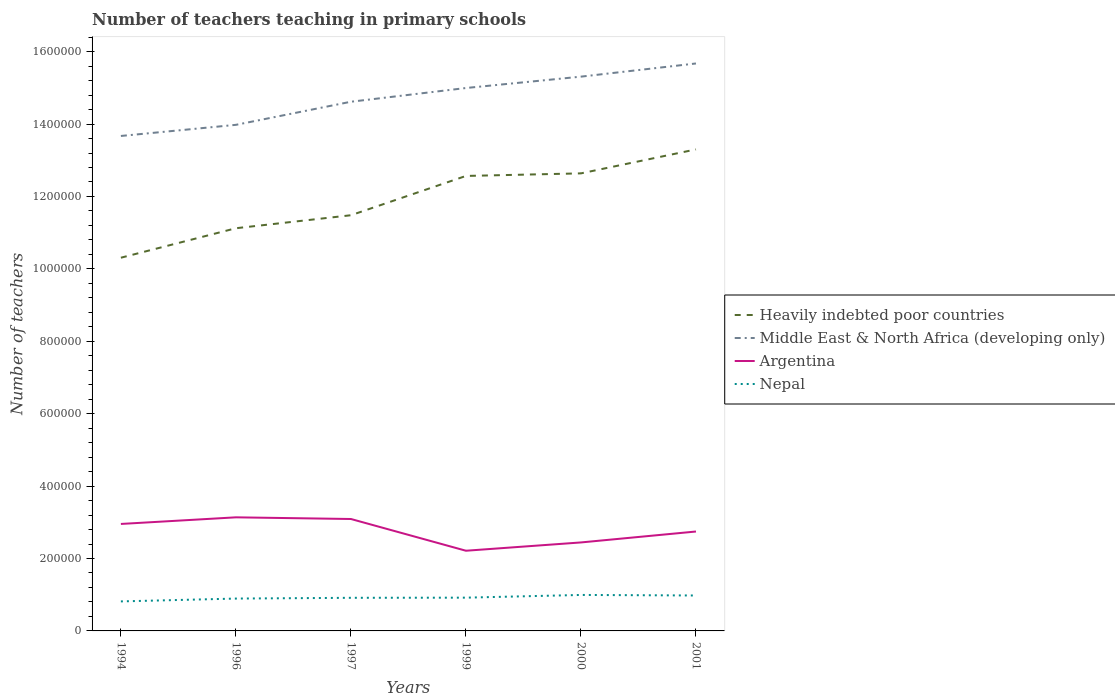How many different coloured lines are there?
Ensure brevity in your answer.  4. Does the line corresponding to Nepal intersect with the line corresponding to Argentina?
Ensure brevity in your answer.  No. Across all years, what is the maximum number of teachers teaching in primary schools in Heavily indebted poor countries?
Offer a terse response. 1.03e+06. What is the total number of teachers teaching in primary schools in Nepal in the graph?
Offer a terse response. -1.63e+04. What is the difference between the highest and the second highest number of teachers teaching in primary schools in Argentina?
Your response must be concise. 9.23e+04. How many years are there in the graph?
Offer a very short reply. 6. What is the difference between two consecutive major ticks on the Y-axis?
Your answer should be very brief. 2.00e+05. Are the values on the major ticks of Y-axis written in scientific E-notation?
Your response must be concise. No. How many legend labels are there?
Make the answer very short. 4. What is the title of the graph?
Offer a very short reply. Number of teachers teaching in primary schools. Does "Austria" appear as one of the legend labels in the graph?
Your answer should be very brief. No. What is the label or title of the Y-axis?
Give a very brief answer. Number of teachers. What is the Number of teachers of Heavily indebted poor countries in 1994?
Offer a very short reply. 1.03e+06. What is the Number of teachers of Middle East & North Africa (developing only) in 1994?
Your response must be concise. 1.37e+06. What is the Number of teachers in Argentina in 1994?
Your answer should be compact. 2.95e+05. What is the Number of teachers of Nepal in 1994?
Your response must be concise. 8.15e+04. What is the Number of teachers in Heavily indebted poor countries in 1996?
Make the answer very short. 1.11e+06. What is the Number of teachers of Middle East & North Africa (developing only) in 1996?
Make the answer very short. 1.40e+06. What is the Number of teachers of Argentina in 1996?
Provide a succinct answer. 3.14e+05. What is the Number of teachers in Nepal in 1996?
Provide a short and direct response. 8.94e+04. What is the Number of teachers of Heavily indebted poor countries in 1997?
Your answer should be compact. 1.15e+06. What is the Number of teachers in Middle East & North Africa (developing only) in 1997?
Provide a short and direct response. 1.46e+06. What is the Number of teachers in Argentina in 1997?
Ensure brevity in your answer.  3.09e+05. What is the Number of teachers of Nepal in 1997?
Make the answer very short. 9.15e+04. What is the Number of teachers in Heavily indebted poor countries in 1999?
Provide a succinct answer. 1.26e+06. What is the Number of teachers in Middle East & North Africa (developing only) in 1999?
Provide a succinct answer. 1.50e+06. What is the Number of teachers in Argentina in 1999?
Your answer should be very brief. 2.21e+05. What is the Number of teachers of Nepal in 1999?
Provide a succinct answer. 9.19e+04. What is the Number of teachers in Heavily indebted poor countries in 2000?
Keep it short and to the point. 1.26e+06. What is the Number of teachers in Middle East & North Africa (developing only) in 2000?
Provide a short and direct response. 1.53e+06. What is the Number of teachers of Argentina in 2000?
Provide a succinct answer. 2.44e+05. What is the Number of teachers in Nepal in 2000?
Provide a succinct answer. 9.94e+04. What is the Number of teachers of Heavily indebted poor countries in 2001?
Give a very brief answer. 1.33e+06. What is the Number of teachers of Middle East & North Africa (developing only) in 2001?
Your response must be concise. 1.57e+06. What is the Number of teachers of Argentina in 2001?
Make the answer very short. 2.75e+05. What is the Number of teachers in Nepal in 2001?
Your answer should be compact. 9.79e+04. Across all years, what is the maximum Number of teachers in Heavily indebted poor countries?
Provide a succinct answer. 1.33e+06. Across all years, what is the maximum Number of teachers of Middle East & North Africa (developing only)?
Give a very brief answer. 1.57e+06. Across all years, what is the maximum Number of teachers of Argentina?
Ensure brevity in your answer.  3.14e+05. Across all years, what is the maximum Number of teachers in Nepal?
Provide a succinct answer. 9.94e+04. Across all years, what is the minimum Number of teachers of Heavily indebted poor countries?
Provide a succinct answer. 1.03e+06. Across all years, what is the minimum Number of teachers of Middle East & North Africa (developing only)?
Your response must be concise. 1.37e+06. Across all years, what is the minimum Number of teachers in Argentina?
Provide a succinct answer. 2.21e+05. Across all years, what is the minimum Number of teachers of Nepal?
Offer a very short reply. 8.15e+04. What is the total Number of teachers in Heavily indebted poor countries in the graph?
Make the answer very short. 7.14e+06. What is the total Number of teachers in Middle East & North Africa (developing only) in the graph?
Offer a very short reply. 8.82e+06. What is the total Number of teachers in Argentina in the graph?
Give a very brief answer. 1.66e+06. What is the total Number of teachers of Nepal in the graph?
Your answer should be compact. 5.52e+05. What is the difference between the Number of teachers in Heavily indebted poor countries in 1994 and that in 1996?
Give a very brief answer. -8.15e+04. What is the difference between the Number of teachers in Middle East & North Africa (developing only) in 1994 and that in 1996?
Keep it short and to the point. -3.07e+04. What is the difference between the Number of teachers of Argentina in 1994 and that in 1996?
Your response must be concise. -1.83e+04. What is the difference between the Number of teachers in Nepal in 1994 and that in 1996?
Make the answer very short. -7834. What is the difference between the Number of teachers of Heavily indebted poor countries in 1994 and that in 1997?
Offer a terse response. -1.17e+05. What is the difference between the Number of teachers in Middle East & North Africa (developing only) in 1994 and that in 1997?
Your answer should be compact. -9.45e+04. What is the difference between the Number of teachers of Argentina in 1994 and that in 1997?
Give a very brief answer. -1.37e+04. What is the difference between the Number of teachers in Nepal in 1994 and that in 1997?
Your response must be concise. -9920. What is the difference between the Number of teachers of Heavily indebted poor countries in 1994 and that in 1999?
Make the answer very short. -2.26e+05. What is the difference between the Number of teachers in Middle East & North Africa (developing only) in 1994 and that in 1999?
Keep it short and to the point. -1.32e+05. What is the difference between the Number of teachers in Argentina in 1994 and that in 1999?
Ensure brevity in your answer.  7.40e+04. What is the difference between the Number of teachers in Nepal in 1994 and that in 1999?
Offer a very short reply. -1.03e+04. What is the difference between the Number of teachers in Heavily indebted poor countries in 1994 and that in 2000?
Offer a very short reply. -2.33e+05. What is the difference between the Number of teachers of Middle East & North Africa (developing only) in 1994 and that in 2000?
Offer a terse response. -1.64e+05. What is the difference between the Number of teachers of Argentina in 1994 and that in 2000?
Make the answer very short. 5.11e+04. What is the difference between the Number of teachers in Nepal in 1994 and that in 2000?
Ensure brevity in your answer.  -1.78e+04. What is the difference between the Number of teachers in Heavily indebted poor countries in 1994 and that in 2001?
Your answer should be compact. -2.99e+05. What is the difference between the Number of teachers in Middle East & North Africa (developing only) in 1994 and that in 2001?
Your answer should be very brief. -2.00e+05. What is the difference between the Number of teachers in Argentina in 1994 and that in 2001?
Your response must be concise. 2.09e+04. What is the difference between the Number of teachers in Nepal in 1994 and that in 2001?
Your answer should be very brief. -1.63e+04. What is the difference between the Number of teachers of Heavily indebted poor countries in 1996 and that in 1997?
Offer a terse response. -3.59e+04. What is the difference between the Number of teachers of Middle East & North Africa (developing only) in 1996 and that in 1997?
Provide a short and direct response. -6.38e+04. What is the difference between the Number of teachers in Argentina in 1996 and that in 1997?
Give a very brief answer. 4602. What is the difference between the Number of teachers in Nepal in 1996 and that in 1997?
Offer a terse response. -2086. What is the difference between the Number of teachers in Heavily indebted poor countries in 1996 and that in 1999?
Offer a very short reply. -1.44e+05. What is the difference between the Number of teachers of Middle East & North Africa (developing only) in 1996 and that in 1999?
Your response must be concise. -1.02e+05. What is the difference between the Number of teachers of Argentina in 1996 and that in 1999?
Give a very brief answer. 9.23e+04. What is the difference between the Number of teachers in Nepal in 1996 and that in 1999?
Your answer should be very brief. -2500. What is the difference between the Number of teachers in Heavily indebted poor countries in 1996 and that in 2000?
Offer a very short reply. -1.52e+05. What is the difference between the Number of teachers of Middle East & North Africa (developing only) in 1996 and that in 2000?
Your answer should be very brief. -1.33e+05. What is the difference between the Number of teachers of Argentina in 1996 and that in 2000?
Your answer should be compact. 6.94e+04. What is the difference between the Number of teachers in Nepal in 1996 and that in 2000?
Provide a succinct answer. -1.00e+04. What is the difference between the Number of teachers of Heavily indebted poor countries in 1996 and that in 2001?
Give a very brief answer. -2.18e+05. What is the difference between the Number of teachers in Middle East & North Africa (developing only) in 1996 and that in 2001?
Your answer should be compact. -1.70e+05. What is the difference between the Number of teachers in Argentina in 1996 and that in 2001?
Ensure brevity in your answer.  3.92e+04. What is the difference between the Number of teachers of Nepal in 1996 and that in 2001?
Offer a very short reply. -8501. What is the difference between the Number of teachers in Heavily indebted poor countries in 1997 and that in 1999?
Offer a very short reply. -1.09e+05. What is the difference between the Number of teachers in Middle East & North Africa (developing only) in 1997 and that in 1999?
Make the answer very short. -3.79e+04. What is the difference between the Number of teachers of Argentina in 1997 and that in 1999?
Offer a terse response. 8.77e+04. What is the difference between the Number of teachers in Nepal in 1997 and that in 1999?
Give a very brief answer. -414. What is the difference between the Number of teachers in Heavily indebted poor countries in 1997 and that in 2000?
Your answer should be very brief. -1.16e+05. What is the difference between the Number of teachers in Middle East & North Africa (developing only) in 1997 and that in 2000?
Give a very brief answer. -6.93e+04. What is the difference between the Number of teachers of Argentina in 1997 and that in 2000?
Provide a short and direct response. 6.48e+04. What is the difference between the Number of teachers of Nepal in 1997 and that in 2000?
Make the answer very short. -7918. What is the difference between the Number of teachers of Heavily indebted poor countries in 1997 and that in 2001?
Ensure brevity in your answer.  -1.82e+05. What is the difference between the Number of teachers of Middle East & North Africa (developing only) in 1997 and that in 2001?
Make the answer very short. -1.06e+05. What is the difference between the Number of teachers in Argentina in 1997 and that in 2001?
Give a very brief answer. 3.46e+04. What is the difference between the Number of teachers of Nepal in 1997 and that in 2001?
Make the answer very short. -6415. What is the difference between the Number of teachers of Heavily indebted poor countries in 1999 and that in 2000?
Give a very brief answer. -7112.5. What is the difference between the Number of teachers of Middle East & North Africa (developing only) in 1999 and that in 2000?
Provide a short and direct response. -3.14e+04. What is the difference between the Number of teachers in Argentina in 1999 and that in 2000?
Your answer should be very brief. -2.29e+04. What is the difference between the Number of teachers in Nepal in 1999 and that in 2000?
Give a very brief answer. -7504. What is the difference between the Number of teachers of Heavily indebted poor countries in 1999 and that in 2001?
Offer a very short reply. -7.33e+04. What is the difference between the Number of teachers in Middle East & North Africa (developing only) in 1999 and that in 2001?
Provide a succinct answer. -6.78e+04. What is the difference between the Number of teachers of Argentina in 1999 and that in 2001?
Make the answer very short. -5.31e+04. What is the difference between the Number of teachers in Nepal in 1999 and that in 2001?
Ensure brevity in your answer.  -6001. What is the difference between the Number of teachers in Heavily indebted poor countries in 2000 and that in 2001?
Make the answer very short. -6.62e+04. What is the difference between the Number of teachers of Middle East & North Africa (developing only) in 2000 and that in 2001?
Provide a succinct answer. -3.64e+04. What is the difference between the Number of teachers in Argentina in 2000 and that in 2001?
Offer a terse response. -3.02e+04. What is the difference between the Number of teachers of Nepal in 2000 and that in 2001?
Your answer should be very brief. 1503. What is the difference between the Number of teachers of Heavily indebted poor countries in 1994 and the Number of teachers of Middle East & North Africa (developing only) in 1996?
Your answer should be very brief. -3.67e+05. What is the difference between the Number of teachers of Heavily indebted poor countries in 1994 and the Number of teachers of Argentina in 1996?
Your answer should be very brief. 7.17e+05. What is the difference between the Number of teachers of Heavily indebted poor countries in 1994 and the Number of teachers of Nepal in 1996?
Offer a terse response. 9.41e+05. What is the difference between the Number of teachers in Middle East & North Africa (developing only) in 1994 and the Number of teachers in Argentina in 1996?
Give a very brief answer. 1.05e+06. What is the difference between the Number of teachers in Middle East & North Africa (developing only) in 1994 and the Number of teachers in Nepal in 1996?
Your response must be concise. 1.28e+06. What is the difference between the Number of teachers in Argentina in 1994 and the Number of teachers in Nepal in 1996?
Provide a short and direct response. 2.06e+05. What is the difference between the Number of teachers of Heavily indebted poor countries in 1994 and the Number of teachers of Middle East & North Africa (developing only) in 1997?
Ensure brevity in your answer.  -4.31e+05. What is the difference between the Number of teachers in Heavily indebted poor countries in 1994 and the Number of teachers in Argentina in 1997?
Make the answer very short. 7.22e+05. What is the difference between the Number of teachers in Heavily indebted poor countries in 1994 and the Number of teachers in Nepal in 1997?
Offer a terse response. 9.39e+05. What is the difference between the Number of teachers in Middle East & North Africa (developing only) in 1994 and the Number of teachers in Argentina in 1997?
Provide a succinct answer. 1.06e+06. What is the difference between the Number of teachers of Middle East & North Africa (developing only) in 1994 and the Number of teachers of Nepal in 1997?
Ensure brevity in your answer.  1.28e+06. What is the difference between the Number of teachers in Argentina in 1994 and the Number of teachers in Nepal in 1997?
Your response must be concise. 2.04e+05. What is the difference between the Number of teachers in Heavily indebted poor countries in 1994 and the Number of teachers in Middle East & North Africa (developing only) in 1999?
Offer a very short reply. -4.69e+05. What is the difference between the Number of teachers of Heavily indebted poor countries in 1994 and the Number of teachers of Argentina in 1999?
Your answer should be compact. 8.09e+05. What is the difference between the Number of teachers of Heavily indebted poor countries in 1994 and the Number of teachers of Nepal in 1999?
Your answer should be compact. 9.39e+05. What is the difference between the Number of teachers of Middle East & North Africa (developing only) in 1994 and the Number of teachers of Argentina in 1999?
Your answer should be compact. 1.15e+06. What is the difference between the Number of teachers of Middle East & North Africa (developing only) in 1994 and the Number of teachers of Nepal in 1999?
Give a very brief answer. 1.28e+06. What is the difference between the Number of teachers in Argentina in 1994 and the Number of teachers in Nepal in 1999?
Give a very brief answer. 2.04e+05. What is the difference between the Number of teachers of Heavily indebted poor countries in 1994 and the Number of teachers of Middle East & North Africa (developing only) in 2000?
Make the answer very short. -5.00e+05. What is the difference between the Number of teachers in Heavily indebted poor countries in 1994 and the Number of teachers in Argentina in 2000?
Keep it short and to the point. 7.86e+05. What is the difference between the Number of teachers in Heavily indebted poor countries in 1994 and the Number of teachers in Nepal in 2000?
Offer a very short reply. 9.31e+05. What is the difference between the Number of teachers of Middle East & North Africa (developing only) in 1994 and the Number of teachers of Argentina in 2000?
Provide a succinct answer. 1.12e+06. What is the difference between the Number of teachers of Middle East & North Africa (developing only) in 1994 and the Number of teachers of Nepal in 2000?
Give a very brief answer. 1.27e+06. What is the difference between the Number of teachers in Argentina in 1994 and the Number of teachers in Nepal in 2000?
Make the answer very short. 1.96e+05. What is the difference between the Number of teachers in Heavily indebted poor countries in 1994 and the Number of teachers in Middle East & North Africa (developing only) in 2001?
Keep it short and to the point. -5.37e+05. What is the difference between the Number of teachers of Heavily indebted poor countries in 1994 and the Number of teachers of Argentina in 2001?
Your answer should be very brief. 7.56e+05. What is the difference between the Number of teachers of Heavily indebted poor countries in 1994 and the Number of teachers of Nepal in 2001?
Make the answer very short. 9.33e+05. What is the difference between the Number of teachers of Middle East & North Africa (developing only) in 1994 and the Number of teachers of Argentina in 2001?
Keep it short and to the point. 1.09e+06. What is the difference between the Number of teachers of Middle East & North Africa (developing only) in 1994 and the Number of teachers of Nepal in 2001?
Keep it short and to the point. 1.27e+06. What is the difference between the Number of teachers of Argentina in 1994 and the Number of teachers of Nepal in 2001?
Your answer should be very brief. 1.98e+05. What is the difference between the Number of teachers of Heavily indebted poor countries in 1996 and the Number of teachers of Middle East & North Africa (developing only) in 1997?
Give a very brief answer. -3.49e+05. What is the difference between the Number of teachers in Heavily indebted poor countries in 1996 and the Number of teachers in Argentina in 1997?
Keep it short and to the point. 8.03e+05. What is the difference between the Number of teachers in Heavily indebted poor countries in 1996 and the Number of teachers in Nepal in 1997?
Ensure brevity in your answer.  1.02e+06. What is the difference between the Number of teachers in Middle East & North Africa (developing only) in 1996 and the Number of teachers in Argentina in 1997?
Provide a short and direct response. 1.09e+06. What is the difference between the Number of teachers of Middle East & North Africa (developing only) in 1996 and the Number of teachers of Nepal in 1997?
Make the answer very short. 1.31e+06. What is the difference between the Number of teachers in Argentina in 1996 and the Number of teachers in Nepal in 1997?
Make the answer very short. 2.22e+05. What is the difference between the Number of teachers in Heavily indebted poor countries in 1996 and the Number of teachers in Middle East & North Africa (developing only) in 1999?
Your answer should be compact. -3.87e+05. What is the difference between the Number of teachers of Heavily indebted poor countries in 1996 and the Number of teachers of Argentina in 1999?
Provide a succinct answer. 8.91e+05. What is the difference between the Number of teachers of Heavily indebted poor countries in 1996 and the Number of teachers of Nepal in 1999?
Your response must be concise. 1.02e+06. What is the difference between the Number of teachers in Middle East & North Africa (developing only) in 1996 and the Number of teachers in Argentina in 1999?
Offer a very short reply. 1.18e+06. What is the difference between the Number of teachers of Middle East & North Africa (developing only) in 1996 and the Number of teachers of Nepal in 1999?
Provide a succinct answer. 1.31e+06. What is the difference between the Number of teachers in Argentina in 1996 and the Number of teachers in Nepal in 1999?
Your answer should be compact. 2.22e+05. What is the difference between the Number of teachers of Heavily indebted poor countries in 1996 and the Number of teachers of Middle East & North Africa (developing only) in 2000?
Make the answer very short. -4.19e+05. What is the difference between the Number of teachers of Heavily indebted poor countries in 1996 and the Number of teachers of Argentina in 2000?
Your answer should be compact. 8.68e+05. What is the difference between the Number of teachers in Heavily indebted poor countries in 1996 and the Number of teachers in Nepal in 2000?
Your answer should be compact. 1.01e+06. What is the difference between the Number of teachers of Middle East & North Africa (developing only) in 1996 and the Number of teachers of Argentina in 2000?
Provide a short and direct response. 1.15e+06. What is the difference between the Number of teachers of Middle East & North Africa (developing only) in 1996 and the Number of teachers of Nepal in 2000?
Give a very brief answer. 1.30e+06. What is the difference between the Number of teachers in Argentina in 1996 and the Number of teachers in Nepal in 2000?
Your answer should be compact. 2.14e+05. What is the difference between the Number of teachers in Heavily indebted poor countries in 1996 and the Number of teachers in Middle East & North Africa (developing only) in 2001?
Your answer should be very brief. -4.55e+05. What is the difference between the Number of teachers in Heavily indebted poor countries in 1996 and the Number of teachers in Argentina in 2001?
Your answer should be very brief. 8.38e+05. What is the difference between the Number of teachers in Heavily indebted poor countries in 1996 and the Number of teachers in Nepal in 2001?
Your response must be concise. 1.01e+06. What is the difference between the Number of teachers in Middle East & North Africa (developing only) in 1996 and the Number of teachers in Argentina in 2001?
Provide a succinct answer. 1.12e+06. What is the difference between the Number of teachers in Middle East & North Africa (developing only) in 1996 and the Number of teachers in Nepal in 2001?
Ensure brevity in your answer.  1.30e+06. What is the difference between the Number of teachers in Argentina in 1996 and the Number of teachers in Nepal in 2001?
Keep it short and to the point. 2.16e+05. What is the difference between the Number of teachers in Heavily indebted poor countries in 1997 and the Number of teachers in Middle East & North Africa (developing only) in 1999?
Offer a terse response. -3.51e+05. What is the difference between the Number of teachers of Heavily indebted poor countries in 1997 and the Number of teachers of Argentina in 1999?
Provide a short and direct response. 9.27e+05. What is the difference between the Number of teachers of Heavily indebted poor countries in 1997 and the Number of teachers of Nepal in 1999?
Make the answer very short. 1.06e+06. What is the difference between the Number of teachers in Middle East & North Africa (developing only) in 1997 and the Number of teachers in Argentina in 1999?
Provide a short and direct response. 1.24e+06. What is the difference between the Number of teachers of Middle East & North Africa (developing only) in 1997 and the Number of teachers of Nepal in 1999?
Make the answer very short. 1.37e+06. What is the difference between the Number of teachers in Argentina in 1997 and the Number of teachers in Nepal in 1999?
Ensure brevity in your answer.  2.17e+05. What is the difference between the Number of teachers in Heavily indebted poor countries in 1997 and the Number of teachers in Middle East & North Africa (developing only) in 2000?
Provide a succinct answer. -3.83e+05. What is the difference between the Number of teachers of Heavily indebted poor countries in 1997 and the Number of teachers of Argentina in 2000?
Your answer should be very brief. 9.04e+05. What is the difference between the Number of teachers in Heavily indebted poor countries in 1997 and the Number of teachers in Nepal in 2000?
Provide a succinct answer. 1.05e+06. What is the difference between the Number of teachers of Middle East & North Africa (developing only) in 1997 and the Number of teachers of Argentina in 2000?
Your answer should be very brief. 1.22e+06. What is the difference between the Number of teachers of Middle East & North Africa (developing only) in 1997 and the Number of teachers of Nepal in 2000?
Your response must be concise. 1.36e+06. What is the difference between the Number of teachers of Argentina in 1997 and the Number of teachers of Nepal in 2000?
Offer a terse response. 2.10e+05. What is the difference between the Number of teachers in Heavily indebted poor countries in 1997 and the Number of teachers in Middle East & North Africa (developing only) in 2001?
Keep it short and to the point. -4.19e+05. What is the difference between the Number of teachers of Heavily indebted poor countries in 1997 and the Number of teachers of Argentina in 2001?
Ensure brevity in your answer.  8.74e+05. What is the difference between the Number of teachers in Heavily indebted poor countries in 1997 and the Number of teachers in Nepal in 2001?
Your answer should be compact. 1.05e+06. What is the difference between the Number of teachers in Middle East & North Africa (developing only) in 1997 and the Number of teachers in Argentina in 2001?
Keep it short and to the point. 1.19e+06. What is the difference between the Number of teachers in Middle East & North Africa (developing only) in 1997 and the Number of teachers in Nepal in 2001?
Make the answer very short. 1.36e+06. What is the difference between the Number of teachers in Argentina in 1997 and the Number of teachers in Nepal in 2001?
Your response must be concise. 2.11e+05. What is the difference between the Number of teachers in Heavily indebted poor countries in 1999 and the Number of teachers in Middle East & North Africa (developing only) in 2000?
Offer a very short reply. -2.74e+05. What is the difference between the Number of teachers in Heavily indebted poor countries in 1999 and the Number of teachers in Argentina in 2000?
Give a very brief answer. 1.01e+06. What is the difference between the Number of teachers in Heavily indebted poor countries in 1999 and the Number of teachers in Nepal in 2000?
Your response must be concise. 1.16e+06. What is the difference between the Number of teachers of Middle East & North Africa (developing only) in 1999 and the Number of teachers of Argentina in 2000?
Offer a terse response. 1.26e+06. What is the difference between the Number of teachers of Middle East & North Africa (developing only) in 1999 and the Number of teachers of Nepal in 2000?
Provide a short and direct response. 1.40e+06. What is the difference between the Number of teachers in Argentina in 1999 and the Number of teachers in Nepal in 2000?
Offer a very short reply. 1.22e+05. What is the difference between the Number of teachers in Heavily indebted poor countries in 1999 and the Number of teachers in Middle East & North Africa (developing only) in 2001?
Make the answer very short. -3.11e+05. What is the difference between the Number of teachers in Heavily indebted poor countries in 1999 and the Number of teachers in Argentina in 2001?
Offer a very short reply. 9.82e+05. What is the difference between the Number of teachers in Heavily indebted poor countries in 1999 and the Number of teachers in Nepal in 2001?
Keep it short and to the point. 1.16e+06. What is the difference between the Number of teachers in Middle East & North Africa (developing only) in 1999 and the Number of teachers in Argentina in 2001?
Make the answer very short. 1.23e+06. What is the difference between the Number of teachers of Middle East & North Africa (developing only) in 1999 and the Number of teachers of Nepal in 2001?
Offer a very short reply. 1.40e+06. What is the difference between the Number of teachers of Argentina in 1999 and the Number of teachers of Nepal in 2001?
Your answer should be very brief. 1.24e+05. What is the difference between the Number of teachers of Heavily indebted poor countries in 2000 and the Number of teachers of Middle East & North Africa (developing only) in 2001?
Provide a short and direct response. -3.04e+05. What is the difference between the Number of teachers of Heavily indebted poor countries in 2000 and the Number of teachers of Argentina in 2001?
Offer a very short reply. 9.89e+05. What is the difference between the Number of teachers of Heavily indebted poor countries in 2000 and the Number of teachers of Nepal in 2001?
Keep it short and to the point. 1.17e+06. What is the difference between the Number of teachers in Middle East & North Africa (developing only) in 2000 and the Number of teachers in Argentina in 2001?
Provide a short and direct response. 1.26e+06. What is the difference between the Number of teachers of Middle East & North Africa (developing only) in 2000 and the Number of teachers of Nepal in 2001?
Make the answer very short. 1.43e+06. What is the difference between the Number of teachers in Argentina in 2000 and the Number of teachers in Nepal in 2001?
Provide a short and direct response. 1.47e+05. What is the average Number of teachers in Heavily indebted poor countries per year?
Offer a very short reply. 1.19e+06. What is the average Number of teachers in Middle East & North Africa (developing only) per year?
Make the answer very short. 1.47e+06. What is the average Number of teachers in Argentina per year?
Your answer should be very brief. 2.76e+05. What is the average Number of teachers in Nepal per year?
Offer a very short reply. 9.19e+04. In the year 1994, what is the difference between the Number of teachers in Heavily indebted poor countries and Number of teachers in Middle East & North Africa (developing only)?
Your response must be concise. -3.36e+05. In the year 1994, what is the difference between the Number of teachers of Heavily indebted poor countries and Number of teachers of Argentina?
Give a very brief answer. 7.35e+05. In the year 1994, what is the difference between the Number of teachers of Heavily indebted poor countries and Number of teachers of Nepal?
Make the answer very short. 9.49e+05. In the year 1994, what is the difference between the Number of teachers in Middle East & North Africa (developing only) and Number of teachers in Argentina?
Provide a succinct answer. 1.07e+06. In the year 1994, what is the difference between the Number of teachers of Middle East & North Africa (developing only) and Number of teachers of Nepal?
Provide a succinct answer. 1.29e+06. In the year 1994, what is the difference between the Number of teachers in Argentina and Number of teachers in Nepal?
Your answer should be compact. 2.14e+05. In the year 1996, what is the difference between the Number of teachers of Heavily indebted poor countries and Number of teachers of Middle East & North Africa (developing only)?
Your answer should be very brief. -2.86e+05. In the year 1996, what is the difference between the Number of teachers in Heavily indebted poor countries and Number of teachers in Argentina?
Ensure brevity in your answer.  7.99e+05. In the year 1996, what is the difference between the Number of teachers in Heavily indebted poor countries and Number of teachers in Nepal?
Your answer should be compact. 1.02e+06. In the year 1996, what is the difference between the Number of teachers of Middle East & North Africa (developing only) and Number of teachers of Argentina?
Provide a succinct answer. 1.08e+06. In the year 1996, what is the difference between the Number of teachers in Middle East & North Africa (developing only) and Number of teachers in Nepal?
Your answer should be very brief. 1.31e+06. In the year 1996, what is the difference between the Number of teachers of Argentina and Number of teachers of Nepal?
Your answer should be compact. 2.24e+05. In the year 1997, what is the difference between the Number of teachers in Heavily indebted poor countries and Number of teachers in Middle East & North Africa (developing only)?
Give a very brief answer. -3.13e+05. In the year 1997, what is the difference between the Number of teachers in Heavily indebted poor countries and Number of teachers in Argentina?
Give a very brief answer. 8.39e+05. In the year 1997, what is the difference between the Number of teachers of Heavily indebted poor countries and Number of teachers of Nepal?
Provide a short and direct response. 1.06e+06. In the year 1997, what is the difference between the Number of teachers of Middle East & North Africa (developing only) and Number of teachers of Argentina?
Provide a short and direct response. 1.15e+06. In the year 1997, what is the difference between the Number of teachers in Middle East & North Africa (developing only) and Number of teachers in Nepal?
Your answer should be compact. 1.37e+06. In the year 1997, what is the difference between the Number of teachers of Argentina and Number of teachers of Nepal?
Your answer should be compact. 2.18e+05. In the year 1999, what is the difference between the Number of teachers in Heavily indebted poor countries and Number of teachers in Middle East & North Africa (developing only)?
Offer a very short reply. -2.43e+05. In the year 1999, what is the difference between the Number of teachers in Heavily indebted poor countries and Number of teachers in Argentina?
Ensure brevity in your answer.  1.04e+06. In the year 1999, what is the difference between the Number of teachers of Heavily indebted poor countries and Number of teachers of Nepal?
Make the answer very short. 1.16e+06. In the year 1999, what is the difference between the Number of teachers in Middle East & North Africa (developing only) and Number of teachers in Argentina?
Provide a short and direct response. 1.28e+06. In the year 1999, what is the difference between the Number of teachers of Middle East & North Africa (developing only) and Number of teachers of Nepal?
Provide a short and direct response. 1.41e+06. In the year 1999, what is the difference between the Number of teachers in Argentina and Number of teachers in Nepal?
Your answer should be compact. 1.30e+05. In the year 2000, what is the difference between the Number of teachers of Heavily indebted poor countries and Number of teachers of Middle East & North Africa (developing only)?
Give a very brief answer. -2.67e+05. In the year 2000, what is the difference between the Number of teachers of Heavily indebted poor countries and Number of teachers of Argentina?
Your answer should be very brief. 1.02e+06. In the year 2000, what is the difference between the Number of teachers in Heavily indebted poor countries and Number of teachers in Nepal?
Offer a very short reply. 1.16e+06. In the year 2000, what is the difference between the Number of teachers of Middle East & North Africa (developing only) and Number of teachers of Argentina?
Keep it short and to the point. 1.29e+06. In the year 2000, what is the difference between the Number of teachers in Middle East & North Africa (developing only) and Number of teachers in Nepal?
Your answer should be very brief. 1.43e+06. In the year 2000, what is the difference between the Number of teachers of Argentina and Number of teachers of Nepal?
Provide a short and direct response. 1.45e+05. In the year 2001, what is the difference between the Number of teachers of Heavily indebted poor countries and Number of teachers of Middle East & North Africa (developing only)?
Ensure brevity in your answer.  -2.37e+05. In the year 2001, what is the difference between the Number of teachers of Heavily indebted poor countries and Number of teachers of Argentina?
Keep it short and to the point. 1.06e+06. In the year 2001, what is the difference between the Number of teachers of Heavily indebted poor countries and Number of teachers of Nepal?
Keep it short and to the point. 1.23e+06. In the year 2001, what is the difference between the Number of teachers in Middle East & North Africa (developing only) and Number of teachers in Argentina?
Provide a short and direct response. 1.29e+06. In the year 2001, what is the difference between the Number of teachers of Middle East & North Africa (developing only) and Number of teachers of Nepal?
Give a very brief answer. 1.47e+06. In the year 2001, what is the difference between the Number of teachers of Argentina and Number of teachers of Nepal?
Provide a succinct answer. 1.77e+05. What is the ratio of the Number of teachers in Heavily indebted poor countries in 1994 to that in 1996?
Keep it short and to the point. 0.93. What is the ratio of the Number of teachers in Middle East & North Africa (developing only) in 1994 to that in 1996?
Offer a very short reply. 0.98. What is the ratio of the Number of teachers in Argentina in 1994 to that in 1996?
Provide a succinct answer. 0.94. What is the ratio of the Number of teachers in Nepal in 1994 to that in 1996?
Offer a terse response. 0.91. What is the ratio of the Number of teachers of Heavily indebted poor countries in 1994 to that in 1997?
Offer a very short reply. 0.9. What is the ratio of the Number of teachers of Middle East & North Africa (developing only) in 1994 to that in 1997?
Offer a very short reply. 0.94. What is the ratio of the Number of teachers in Argentina in 1994 to that in 1997?
Provide a succinct answer. 0.96. What is the ratio of the Number of teachers in Nepal in 1994 to that in 1997?
Give a very brief answer. 0.89. What is the ratio of the Number of teachers of Heavily indebted poor countries in 1994 to that in 1999?
Offer a terse response. 0.82. What is the ratio of the Number of teachers of Middle East & North Africa (developing only) in 1994 to that in 1999?
Offer a terse response. 0.91. What is the ratio of the Number of teachers of Argentina in 1994 to that in 1999?
Make the answer very short. 1.33. What is the ratio of the Number of teachers in Nepal in 1994 to that in 1999?
Ensure brevity in your answer.  0.89. What is the ratio of the Number of teachers of Heavily indebted poor countries in 1994 to that in 2000?
Ensure brevity in your answer.  0.82. What is the ratio of the Number of teachers in Middle East & North Africa (developing only) in 1994 to that in 2000?
Offer a very short reply. 0.89. What is the ratio of the Number of teachers in Argentina in 1994 to that in 2000?
Offer a terse response. 1.21. What is the ratio of the Number of teachers of Nepal in 1994 to that in 2000?
Provide a short and direct response. 0.82. What is the ratio of the Number of teachers of Heavily indebted poor countries in 1994 to that in 2001?
Provide a succinct answer. 0.78. What is the ratio of the Number of teachers in Middle East & North Africa (developing only) in 1994 to that in 2001?
Your answer should be compact. 0.87. What is the ratio of the Number of teachers in Argentina in 1994 to that in 2001?
Your answer should be compact. 1.08. What is the ratio of the Number of teachers of Nepal in 1994 to that in 2001?
Your response must be concise. 0.83. What is the ratio of the Number of teachers in Heavily indebted poor countries in 1996 to that in 1997?
Give a very brief answer. 0.97. What is the ratio of the Number of teachers in Middle East & North Africa (developing only) in 1996 to that in 1997?
Ensure brevity in your answer.  0.96. What is the ratio of the Number of teachers of Argentina in 1996 to that in 1997?
Give a very brief answer. 1.01. What is the ratio of the Number of teachers in Nepal in 1996 to that in 1997?
Offer a terse response. 0.98. What is the ratio of the Number of teachers of Heavily indebted poor countries in 1996 to that in 1999?
Make the answer very short. 0.89. What is the ratio of the Number of teachers of Middle East & North Africa (developing only) in 1996 to that in 1999?
Your answer should be compact. 0.93. What is the ratio of the Number of teachers of Argentina in 1996 to that in 1999?
Offer a terse response. 1.42. What is the ratio of the Number of teachers of Nepal in 1996 to that in 1999?
Your answer should be compact. 0.97. What is the ratio of the Number of teachers of Heavily indebted poor countries in 1996 to that in 2000?
Offer a terse response. 0.88. What is the ratio of the Number of teachers in Argentina in 1996 to that in 2000?
Make the answer very short. 1.28. What is the ratio of the Number of teachers of Nepal in 1996 to that in 2000?
Keep it short and to the point. 0.9. What is the ratio of the Number of teachers of Heavily indebted poor countries in 1996 to that in 2001?
Provide a succinct answer. 0.84. What is the ratio of the Number of teachers of Middle East & North Africa (developing only) in 1996 to that in 2001?
Provide a short and direct response. 0.89. What is the ratio of the Number of teachers of Argentina in 1996 to that in 2001?
Your answer should be compact. 1.14. What is the ratio of the Number of teachers of Nepal in 1996 to that in 2001?
Keep it short and to the point. 0.91. What is the ratio of the Number of teachers in Heavily indebted poor countries in 1997 to that in 1999?
Your response must be concise. 0.91. What is the ratio of the Number of teachers in Middle East & North Africa (developing only) in 1997 to that in 1999?
Offer a very short reply. 0.97. What is the ratio of the Number of teachers of Argentina in 1997 to that in 1999?
Give a very brief answer. 1.4. What is the ratio of the Number of teachers in Heavily indebted poor countries in 1997 to that in 2000?
Ensure brevity in your answer.  0.91. What is the ratio of the Number of teachers of Middle East & North Africa (developing only) in 1997 to that in 2000?
Offer a very short reply. 0.95. What is the ratio of the Number of teachers in Argentina in 1997 to that in 2000?
Your answer should be compact. 1.26. What is the ratio of the Number of teachers of Nepal in 1997 to that in 2000?
Your response must be concise. 0.92. What is the ratio of the Number of teachers of Heavily indebted poor countries in 1997 to that in 2001?
Your answer should be compact. 0.86. What is the ratio of the Number of teachers in Middle East & North Africa (developing only) in 1997 to that in 2001?
Ensure brevity in your answer.  0.93. What is the ratio of the Number of teachers of Argentina in 1997 to that in 2001?
Your answer should be very brief. 1.13. What is the ratio of the Number of teachers of Nepal in 1997 to that in 2001?
Your response must be concise. 0.93. What is the ratio of the Number of teachers of Middle East & North Africa (developing only) in 1999 to that in 2000?
Your answer should be compact. 0.98. What is the ratio of the Number of teachers of Argentina in 1999 to that in 2000?
Make the answer very short. 0.91. What is the ratio of the Number of teachers in Nepal in 1999 to that in 2000?
Provide a short and direct response. 0.92. What is the ratio of the Number of teachers of Heavily indebted poor countries in 1999 to that in 2001?
Offer a terse response. 0.94. What is the ratio of the Number of teachers in Middle East & North Africa (developing only) in 1999 to that in 2001?
Your response must be concise. 0.96. What is the ratio of the Number of teachers in Argentina in 1999 to that in 2001?
Make the answer very short. 0.81. What is the ratio of the Number of teachers of Nepal in 1999 to that in 2001?
Provide a succinct answer. 0.94. What is the ratio of the Number of teachers of Heavily indebted poor countries in 2000 to that in 2001?
Keep it short and to the point. 0.95. What is the ratio of the Number of teachers of Middle East & North Africa (developing only) in 2000 to that in 2001?
Your answer should be compact. 0.98. What is the ratio of the Number of teachers of Argentina in 2000 to that in 2001?
Make the answer very short. 0.89. What is the ratio of the Number of teachers of Nepal in 2000 to that in 2001?
Your response must be concise. 1.02. What is the difference between the highest and the second highest Number of teachers in Heavily indebted poor countries?
Make the answer very short. 6.62e+04. What is the difference between the highest and the second highest Number of teachers in Middle East & North Africa (developing only)?
Provide a succinct answer. 3.64e+04. What is the difference between the highest and the second highest Number of teachers in Argentina?
Your response must be concise. 4602. What is the difference between the highest and the second highest Number of teachers in Nepal?
Ensure brevity in your answer.  1503. What is the difference between the highest and the lowest Number of teachers of Heavily indebted poor countries?
Keep it short and to the point. 2.99e+05. What is the difference between the highest and the lowest Number of teachers of Middle East & North Africa (developing only)?
Make the answer very short. 2.00e+05. What is the difference between the highest and the lowest Number of teachers in Argentina?
Offer a terse response. 9.23e+04. What is the difference between the highest and the lowest Number of teachers in Nepal?
Give a very brief answer. 1.78e+04. 